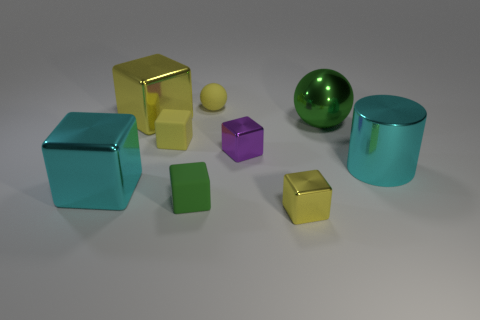Subtract all green cubes. How many cubes are left? 5 Add 1 tiny cyan objects. How many objects exist? 10 Subtract all cyan blocks. How many blocks are left? 5 Subtract all spheres. How many objects are left? 7 Subtract all gray cylinders. How many red spheres are left? 0 Add 6 yellow matte spheres. How many yellow matte spheres exist? 7 Subtract 1 green cubes. How many objects are left? 8 Subtract 1 cylinders. How many cylinders are left? 0 Subtract all green cubes. Subtract all cyan spheres. How many cubes are left? 5 Subtract all yellow matte things. Subtract all green cubes. How many objects are left? 6 